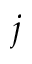<formula> <loc_0><loc_0><loc_500><loc_500>j</formula> 